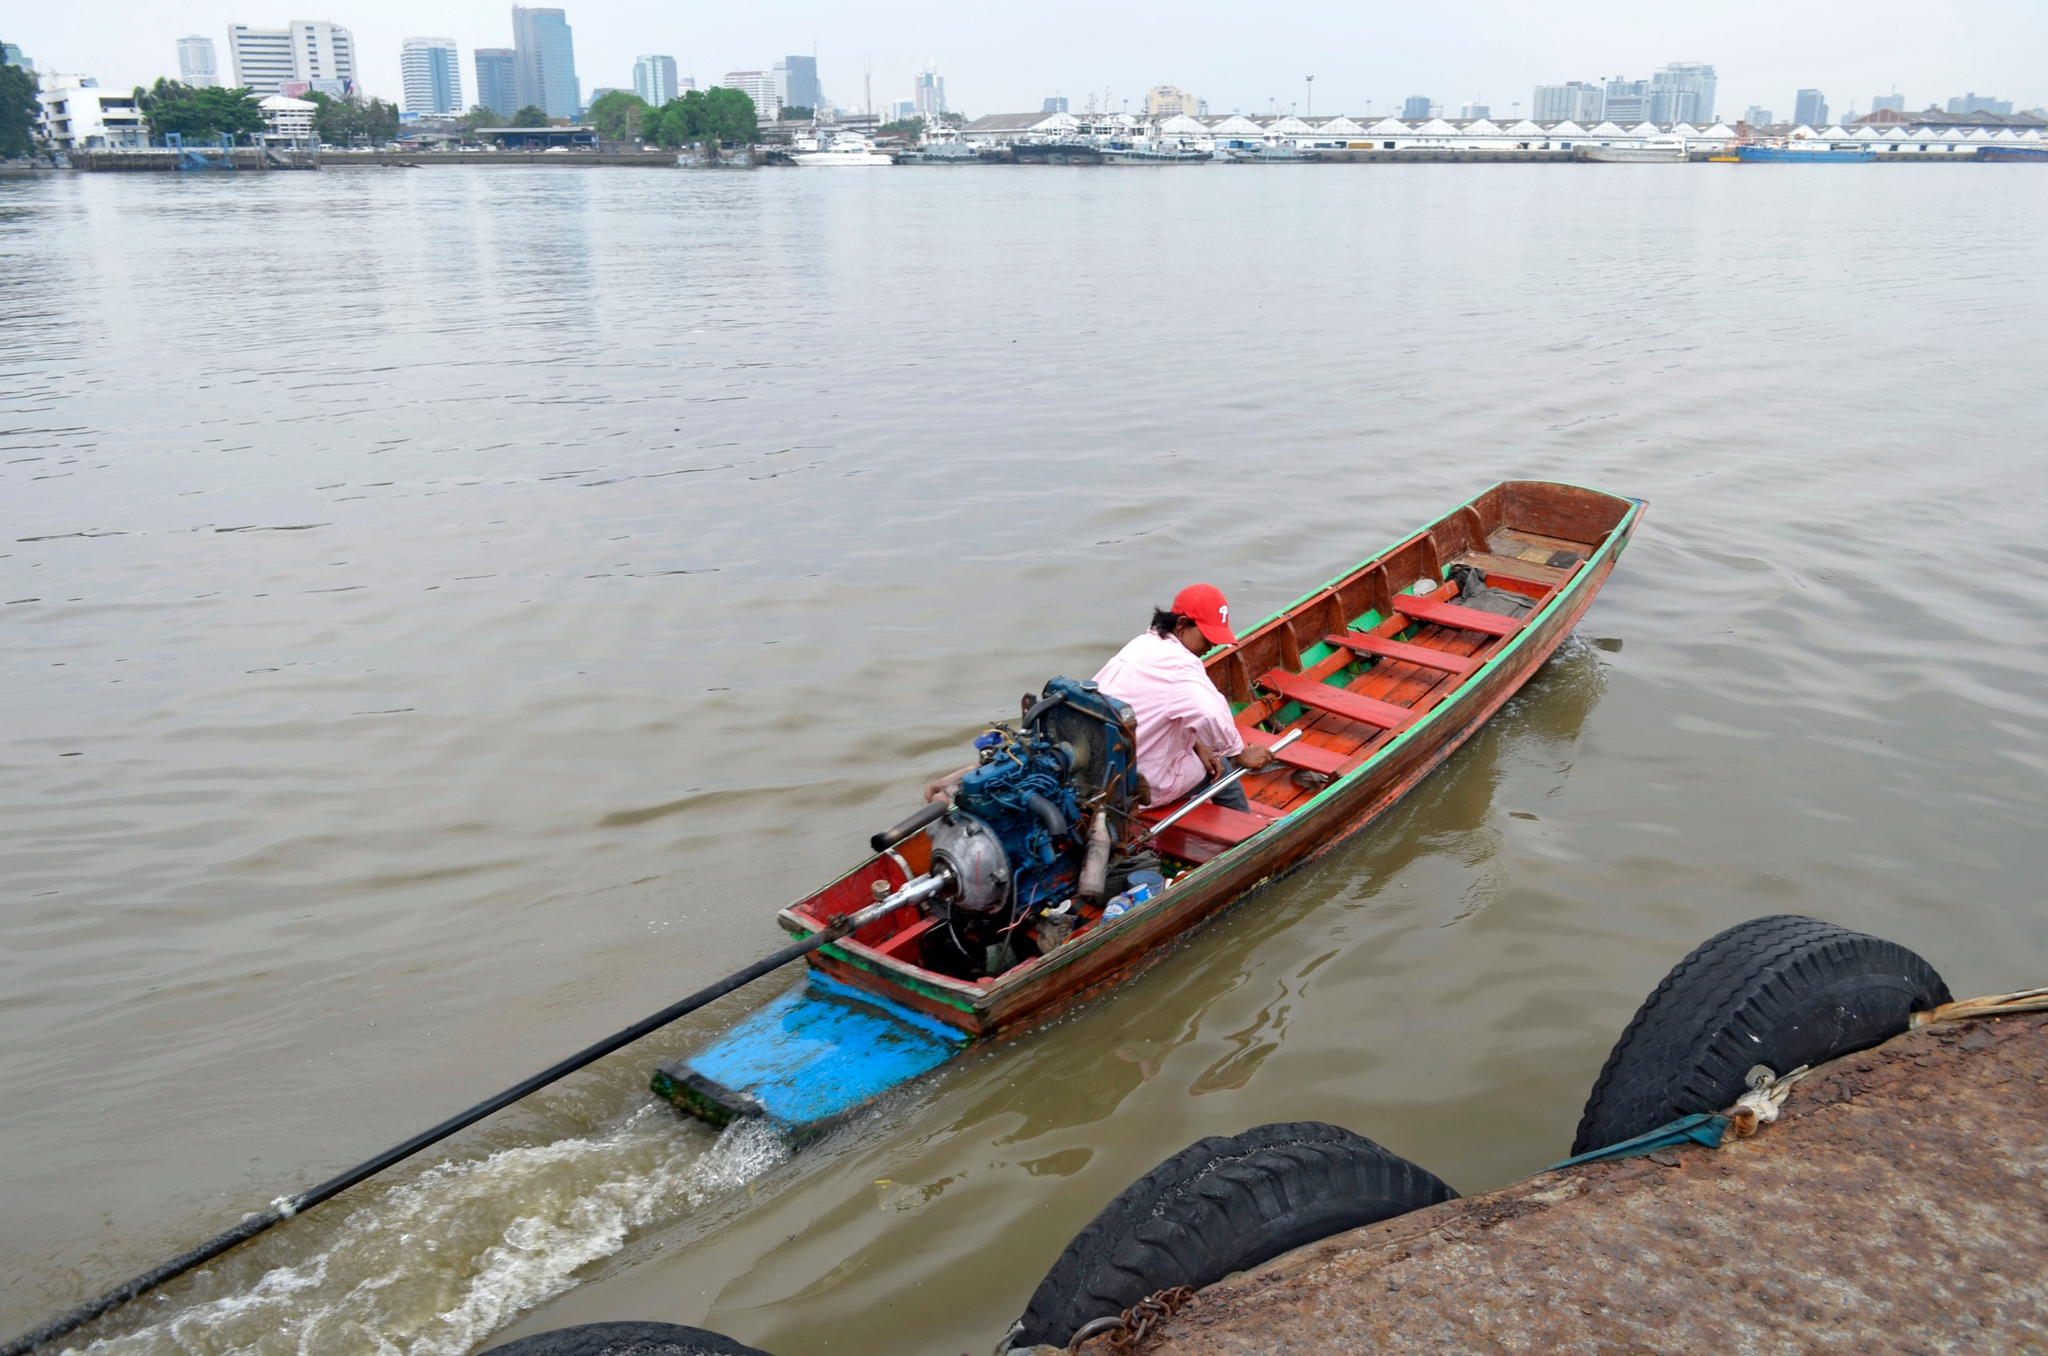Create a short and poetic description of the person's boat ride. In a wooden vessel painted red and blue,
A journey unfolds on waters true,
Ripples dance in a gentle breeze,
As overcast skies whisper with ease.

The city's outline, a distant mirage,
Blends with the river, a tranquil collage,
Peace is found in the rhythmic glide,
On this serene, enchanting ride. 